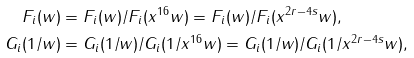<formula> <loc_0><loc_0><loc_500><loc_500>\ F _ { i } ( w ) & = F _ { i } ( w ) / F _ { i } ( x ^ { 1 6 } w ) = F _ { i } ( w ) / F _ { i } ( x ^ { 2 r - 4 s } w ) , \\ \ G _ { i } ( 1 / w ) & = G _ { i } ( 1 / w ) / G _ { i } ( 1 / x ^ { 1 6 } w ) = G _ { i } ( 1 / w ) / G _ { i } ( 1 / x ^ { 2 r - 4 s } w ) ,</formula> 